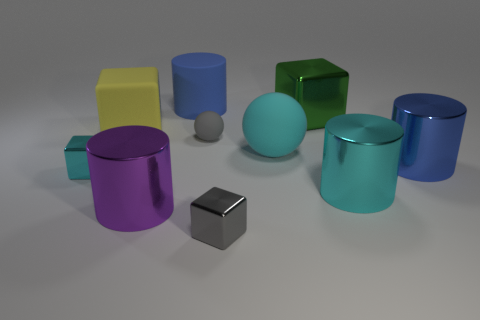What shape is the big shiny thing behind the small gray object on the left side of the small shiny block that is on the right side of the cyan shiny block?
Keep it short and to the point. Cube. Are there an equal number of big cylinders that are to the right of the matte cylinder and cyan rubber spheres?
Make the answer very short. No. Does the green shiny thing have the same size as the cyan shiny cube?
Offer a very short reply. No. What number of rubber objects are large brown balls or green cubes?
Your answer should be very brief. 0. There is a yellow cube that is the same size as the green metal thing; what is it made of?
Your answer should be compact. Rubber. What number of other objects are there of the same material as the green block?
Make the answer very short. 5. Is the number of rubber objects that are in front of the cyan cube less than the number of small gray spheres?
Your answer should be very brief. Yes. Do the green metal thing and the cyan matte object have the same shape?
Keep it short and to the point. No. There is a thing that is to the right of the large cyan thing that is in front of the big blue cylinder right of the rubber cylinder; how big is it?
Give a very brief answer. Large. There is another cyan object that is the same shape as the small matte object; what is its material?
Provide a short and direct response. Rubber. 